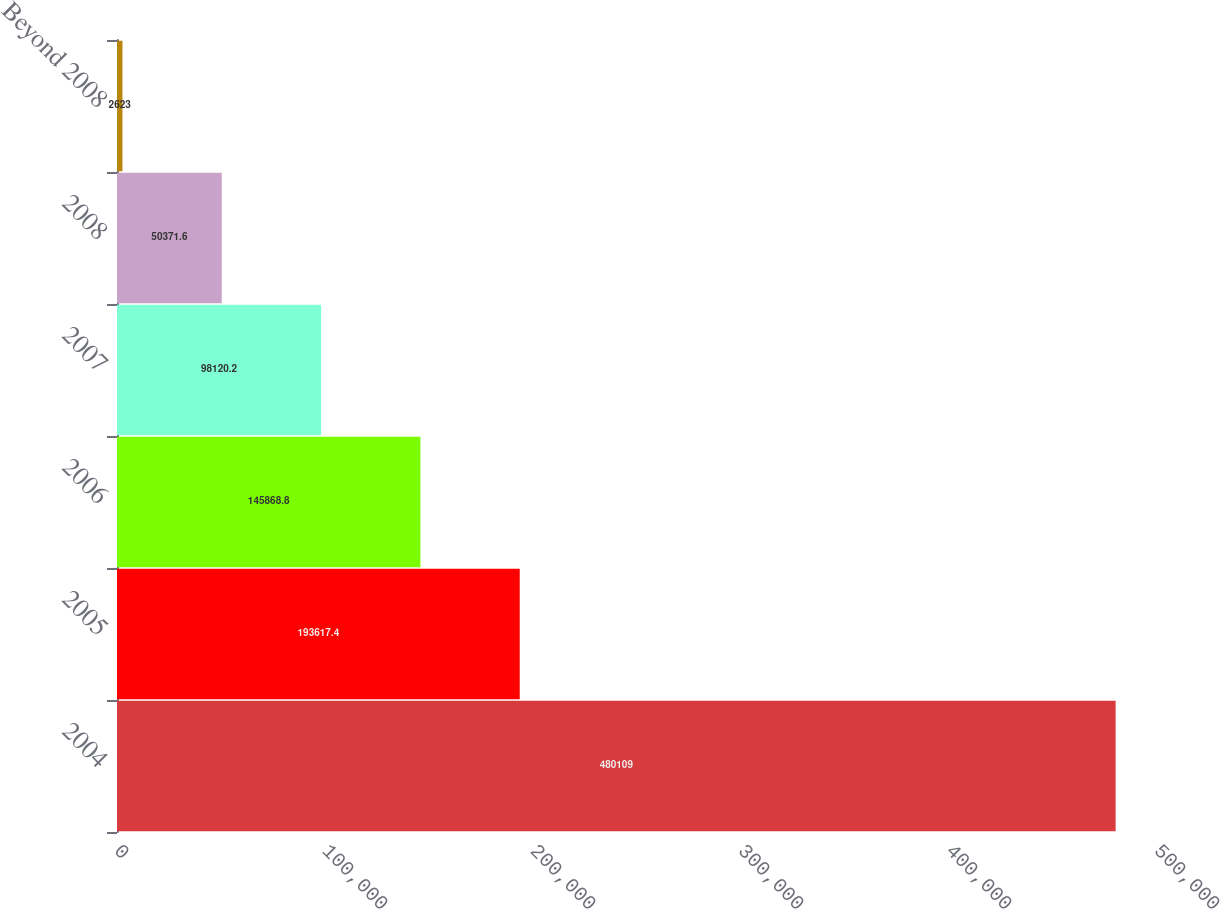Convert chart. <chart><loc_0><loc_0><loc_500><loc_500><bar_chart><fcel>2004<fcel>2005<fcel>2006<fcel>2007<fcel>2008<fcel>Beyond 2008<nl><fcel>480109<fcel>193617<fcel>145869<fcel>98120.2<fcel>50371.6<fcel>2623<nl></chart> 